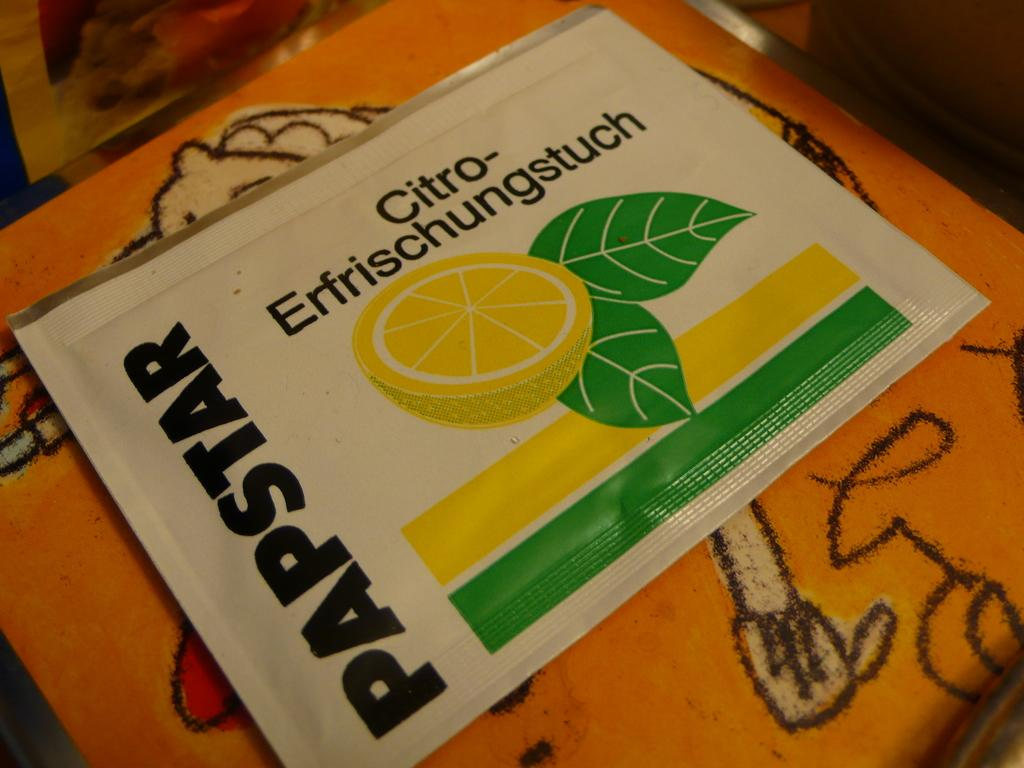What is the main subject of the image? There is an object in the image. What is depicted on the object? The object has an image of a sliced lemon on it. Are there any other decorative elements on the object? Yes, the object has two leaves on it. What can be seen beside and above the object? There is writing beside and above the object. How many sheep can be seen grazing in the background of the image? There are no sheep present in the image; it only features an object with a sliced lemon and leaves. What month is it according to the calendar in the image? There is no calendar present in the image. 